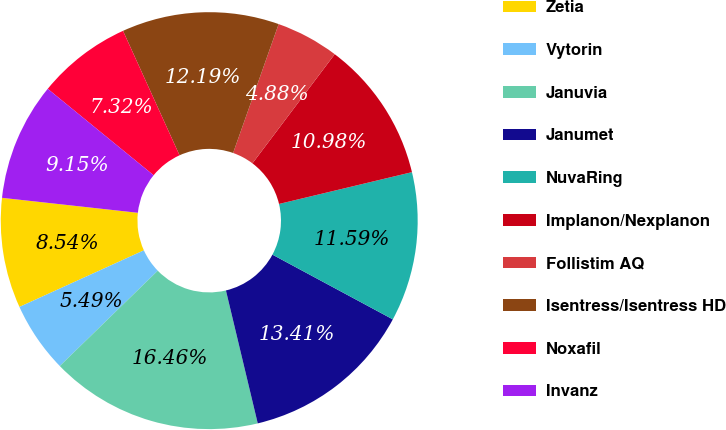Convert chart. <chart><loc_0><loc_0><loc_500><loc_500><pie_chart><fcel>Zetia<fcel>Vytorin<fcel>Januvia<fcel>Janumet<fcel>NuvaRing<fcel>Implanon/Nexplanon<fcel>Follistim AQ<fcel>Isentress/Isentress HD<fcel>Noxafil<fcel>Invanz<nl><fcel>8.54%<fcel>5.49%<fcel>16.46%<fcel>13.41%<fcel>11.59%<fcel>10.98%<fcel>4.88%<fcel>12.19%<fcel>7.32%<fcel>9.15%<nl></chart> 